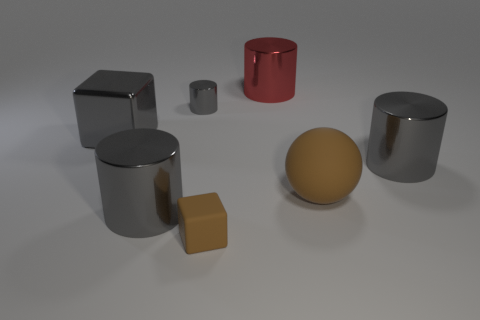Subtract all gray cylinders. How many were subtracted if there are1gray cylinders left? 2 Subtract all gray shiny cylinders. How many cylinders are left? 1 Subtract all brown blocks. How many blocks are left? 1 Subtract all balls. How many objects are left? 6 Subtract 1 cylinders. How many cylinders are left? 3 Add 2 cyan metallic things. How many objects exist? 9 Subtract 0 green spheres. How many objects are left? 7 Subtract all red cylinders. Subtract all cyan spheres. How many cylinders are left? 3 Subtract all cyan cylinders. How many blue spheres are left? 0 Subtract all red things. Subtract all tiny gray cylinders. How many objects are left? 5 